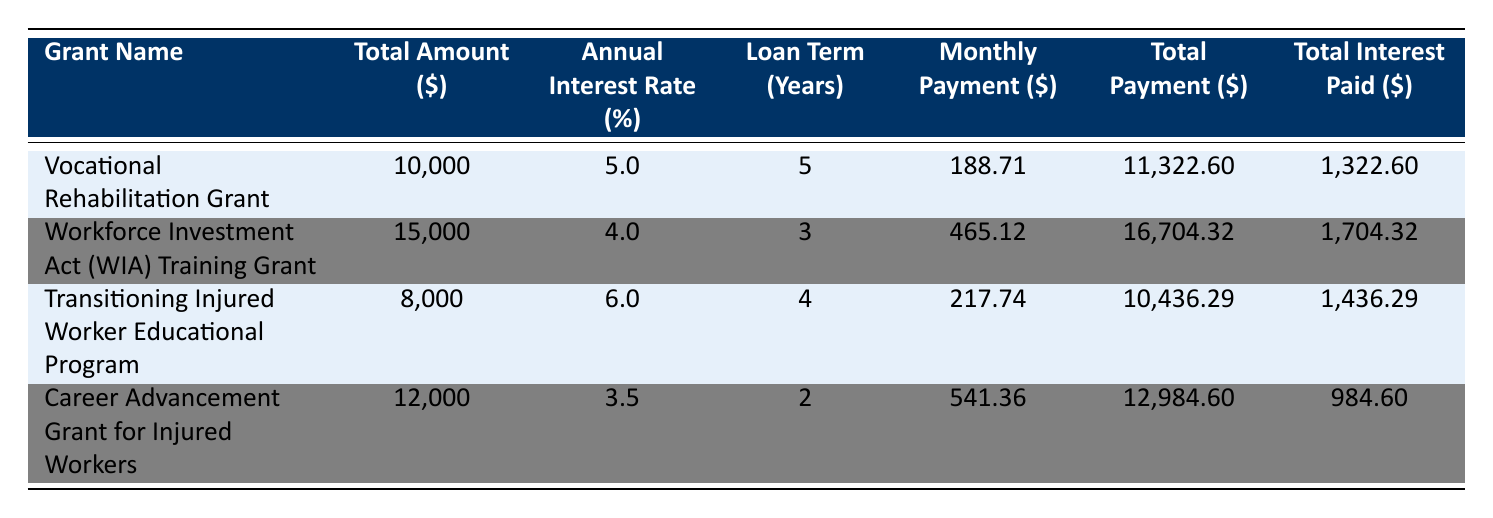What is the total amount for the Workforce Investment Act (WIA) Training Grant? The total amount for the Workforce Investment Act (WIA) Training Grant is clearly listed in the table under the "Total Amount ($)" column for that grant, which states 15,000.
Answer: 15,000 Which grant has the highest total interest paid? By examining the "Total Interest Paid ($)" column, the total interest paid for each grant is compared. The Workforce Investment Act (WIA) Training Grant shows 1,704.32, which is greater than the others: Vocational Rehabilitation Grant (1,322.60), Transitioning Injured Worker Educational Program (1,436.29), and Career Advancement Grant for Injured Workers (984.60).
Answer: Workforce Investment Act (WIA) Training Grant What is the average monthly payment across all grants? To find the average monthly payment, the monthly payments for all grants are summed: 188.71 + 465.12 + 217.74 + 541.36 = 1,413.93. This total is divided by the number of grants (4), resulting in 1,413.93 / 4 = 353.48.
Answer: 353.48 Is the total amount of the Transitioning Injured Worker Educational Program greater than the Career Advancement Grant for Injured Workers? The total amounts for the Transitioning Injured Worker Educational Program (8,000) and the Career Advancement Grant for Injured Workers (12,000) are compared. Since 8,000 is less than 12,000, the statement is false.
Answer: No If all grants are paid off, how much total interest will have been paid? To find the total interest paid across all grants, the values from the "Total Interest Paid ($)" column are added: 1,322.60 + 1,704.32 + 1,436.29 + 984.60 = 5,447.81. This gives the total interest paid when all grants are paid off.
Answer: 5,447.81 Which grant has the lowest annual interest rate? The "Annual Interest Rate (%)" for each grant is reviewed. The Career Advancement Grant for Injured Workers has an interest rate of 3.5%, which is lower than the others: Vocational Rehabilitation Grant (5.0%), Workforce Investment Act (WIA) Training Grant (4.0%), and Transitioning Injured Worker Educational Program (6.0%).
Answer: Career Advancement Grant for Injured Workers What is the total payment for the Vocational Rehabilitation Grant? The total payment for the Vocational Rehabilitation Grant is provided in the table under the "Total Payment ($)" column, which states 11,322.60.
Answer: 11,322.60 How much more will be paid in total for the Workforce Investment Act (WIA) Training Grant compared to the Transitioning Injured Worker Educational Program? The total payment for the Workforce Investment Act (WIA) Training Grant is 16,704.32 and for the Transitioning Injured Worker Educational Program it is 10,436.29. The difference is calculated as 16,704.32 - 10,436.29 = 6,268.03.
Answer: 6,268.03 